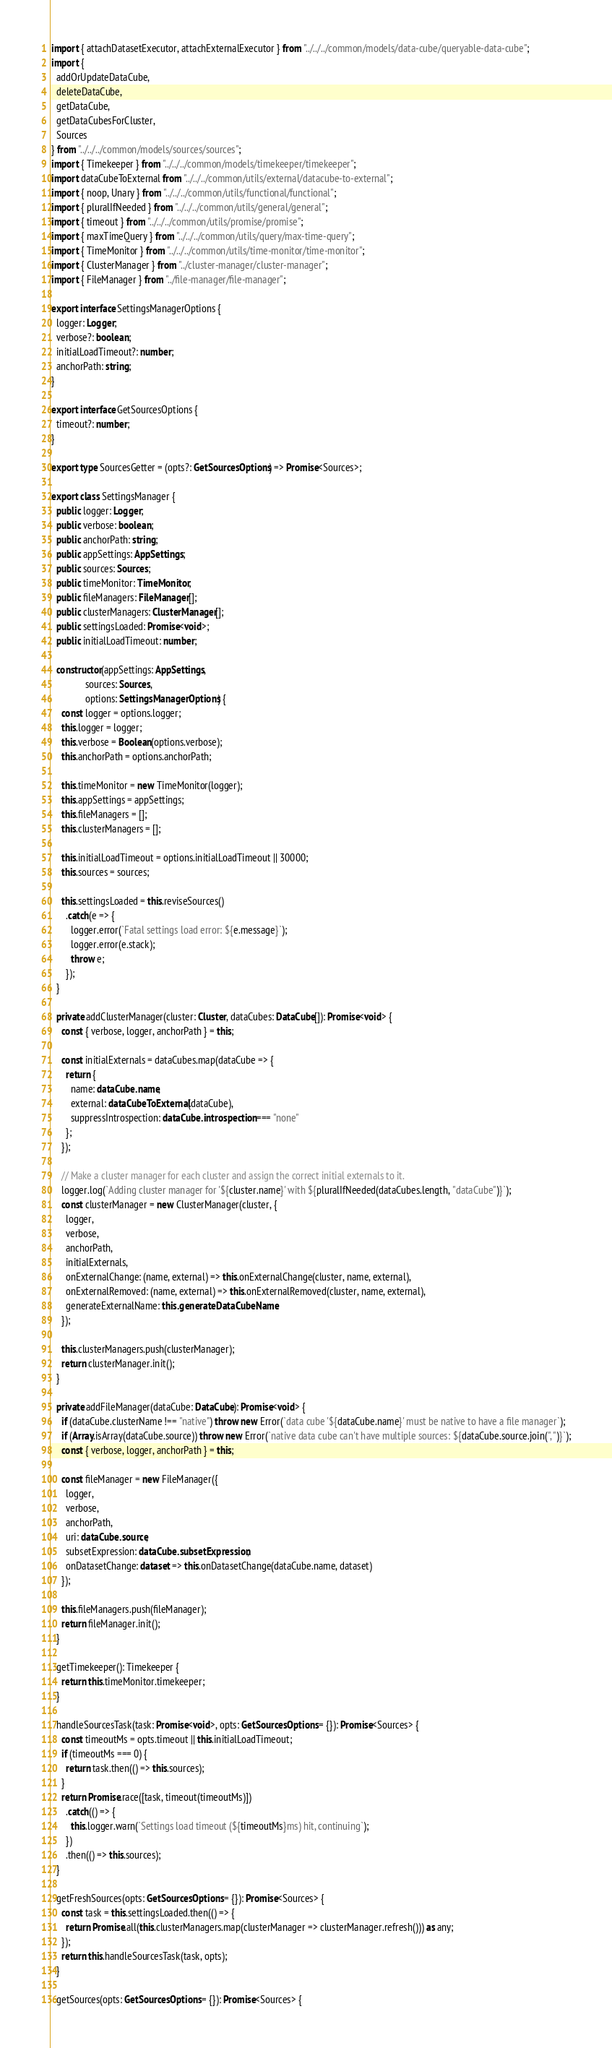<code> <loc_0><loc_0><loc_500><loc_500><_TypeScript_>import { attachDatasetExecutor, attachExternalExecutor } from "../../../common/models/data-cube/queryable-data-cube";
import {
  addOrUpdateDataCube,
  deleteDataCube,
  getDataCube,
  getDataCubesForCluster,
  Sources
} from "../../../common/models/sources/sources";
import { Timekeeper } from "../../../common/models/timekeeper/timekeeper";
import dataCubeToExternal from "../../../common/utils/external/datacube-to-external";
import { noop, Unary } from "../../../common/utils/functional/functional";
import { pluralIfNeeded } from "../../../common/utils/general/general";
import { timeout } from "../../../common/utils/promise/promise";
import { maxTimeQuery } from "../../../common/utils/query/max-time-query";
import { TimeMonitor } from "../../../common/utils/time-monitor/time-monitor";
import { ClusterManager } from "../cluster-manager/cluster-manager";
import { FileManager } from "../file-manager/file-manager";

export interface SettingsManagerOptions {
  logger: Logger;
  verbose?: boolean;
  initialLoadTimeout?: number;
  anchorPath: string;
}

export interface GetSourcesOptions {
  timeout?: number;
}

export type SourcesGetter = (opts?: GetSourcesOptions) => Promise<Sources>;

export class SettingsManager {
  public logger: Logger;
  public verbose: boolean;
  public anchorPath: string;
  public appSettings: AppSettings;
  public sources: Sources;
  public timeMonitor: TimeMonitor;
  public fileManagers: FileManager[];
  public clusterManagers: ClusterManager[];
  public settingsLoaded: Promise<void>;
  public initialLoadTimeout: number;

  constructor(appSettings: AppSettings,
              sources: Sources,
              options: SettingsManagerOptions) {
    const logger = options.logger;
    this.logger = logger;
    this.verbose = Boolean(options.verbose);
    this.anchorPath = options.anchorPath;

    this.timeMonitor = new TimeMonitor(logger);
    this.appSettings = appSettings;
    this.fileManagers = [];
    this.clusterManagers = [];

    this.initialLoadTimeout = options.initialLoadTimeout || 30000;
    this.sources = sources;

    this.settingsLoaded = this.reviseSources()
      .catch(e => {
        logger.error(`Fatal settings load error: ${e.message}`);
        logger.error(e.stack);
        throw e;
      });
  }

  private addClusterManager(cluster: Cluster, dataCubes: DataCube[]): Promise<void> {
    const { verbose, logger, anchorPath } = this;

    const initialExternals = dataCubes.map(dataCube => {
      return {
        name: dataCube.name,
        external: dataCubeToExternal(dataCube),
        suppressIntrospection: dataCube.introspection === "none"
      };
    });

    // Make a cluster manager for each cluster and assign the correct initial externals to it.
    logger.log(`Adding cluster manager for '${cluster.name}' with ${pluralIfNeeded(dataCubes.length, "dataCube")}`);
    const clusterManager = new ClusterManager(cluster, {
      logger,
      verbose,
      anchorPath,
      initialExternals,
      onExternalChange: (name, external) => this.onExternalChange(cluster, name, external),
      onExternalRemoved: (name, external) => this.onExternalRemoved(cluster, name, external),
      generateExternalName: this.generateDataCubeName
    });

    this.clusterManagers.push(clusterManager);
    return clusterManager.init();
  }

  private addFileManager(dataCube: DataCube): Promise<void> {
    if (dataCube.clusterName !== "native") throw new Error(`data cube '${dataCube.name}' must be native to have a file manager`);
    if (Array.isArray(dataCube.source)) throw new Error(`native data cube can't have multiple sources: ${dataCube.source.join(", ")}`);
    const { verbose, logger, anchorPath } = this;

    const fileManager = new FileManager({
      logger,
      verbose,
      anchorPath,
      uri: dataCube.source,
      subsetExpression: dataCube.subsetExpression,
      onDatasetChange: dataset => this.onDatasetChange(dataCube.name, dataset)
    });

    this.fileManagers.push(fileManager);
    return fileManager.init();
  }

  getTimekeeper(): Timekeeper {
    return this.timeMonitor.timekeeper;
  }

  handleSourcesTask(task: Promise<void>, opts: GetSourcesOptions = {}): Promise<Sources> {
    const timeoutMs = opts.timeout || this.initialLoadTimeout;
    if (timeoutMs === 0) {
      return task.then(() => this.sources);
    }
    return Promise.race([task, timeout(timeoutMs)])
      .catch(() => {
        this.logger.warn(`Settings load timeout (${timeoutMs}ms) hit, continuing`);
      })
      .then(() => this.sources);
  }

  getFreshSources(opts: GetSourcesOptions = {}): Promise<Sources> {
    const task = this.settingsLoaded.then(() => {
      return Promise.all(this.clusterManagers.map(clusterManager => clusterManager.refresh())) as any;
    });
    return this.handleSourcesTask(task, opts);
  }

  getSources(opts: GetSourcesOptions = {}): Promise<Sources> {</code> 